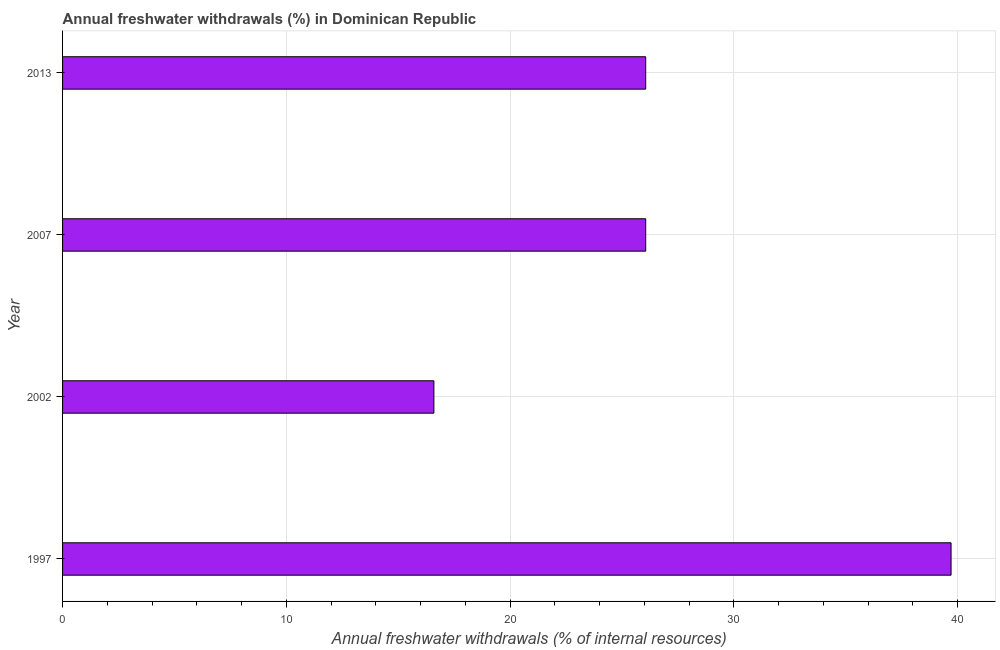Does the graph contain any zero values?
Your answer should be compact. No. What is the title of the graph?
Offer a very short reply. Annual freshwater withdrawals (%) in Dominican Republic. What is the label or title of the X-axis?
Your response must be concise. Annual freshwater withdrawals (% of internal resources). What is the label or title of the Y-axis?
Provide a succinct answer. Year. What is the annual freshwater withdrawals in 2002?
Keep it short and to the point. 16.6. Across all years, what is the maximum annual freshwater withdrawals?
Ensure brevity in your answer.  39.71. Across all years, what is the minimum annual freshwater withdrawals?
Give a very brief answer. 16.6. In which year was the annual freshwater withdrawals maximum?
Your response must be concise. 1997. In which year was the annual freshwater withdrawals minimum?
Give a very brief answer. 2002. What is the sum of the annual freshwater withdrawals?
Ensure brevity in your answer.  108.43. What is the difference between the annual freshwater withdrawals in 1997 and 2013?
Offer a terse response. 13.65. What is the average annual freshwater withdrawals per year?
Your response must be concise. 27.11. What is the median annual freshwater withdrawals?
Your answer should be very brief. 26.06. In how many years, is the annual freshwater withdrawals greater than 26 %?
Your answer should be very brief. 3. Do a majority of the years between 2002 and 2013 (inclusive) have annual freshwater withdrawals greater than 34 %?
Provide a succinct answer. No. What is the ratio of the annual freshwater withdrawals in 1997 to that in 2002?
Your answer should be compact. 2.39. Is the difference between the annual freshwater withdrawals in 2002 and 2007 greater than the difference between any two years?
Make the answer very short. No. What is the difference between the highest and the second highest annual freshwater withdrawals?
Ensure brevity in your answer.  13.65. What is the difference between the highest and the lowest annual freshwater withdrawals?
Your response must be concise. 23.11. Are all the bars in the graph horizontal?
Provide a succinct answer. Yes. How many years are there in the graph?
Give a very brief answer. 4. What is the difference between two consecutive major ticks on the X-axis?
Keep it short and to the point. 10. What is the Annual freshwater withdrawals (% of internal resources) of 1997?
Provide a short and direct response. 39.71. What is the Annual freshwater withdrawals (% of internal resources) of 2002?
Provide a succinct answer. 16.6. What is the Annual freshwater withdrawals (% of internal resources) of 2007?
Make the answer very short. 26.06. What is the Annual freshwater withdrawals (% of internal resources) of 2013?
Your response must be concise. 26.06. What is the difference between the Annual freshwater withdrawals (% of internal resources) in 1997 and 2002?
Make the answer very short. 23.11. What is the difference between the Annual freshwater withdrawals (% of internal resources) in 1997 and 2007?
Your answer should be compact. 13.65. What is the difference between the Annual freshwater withdrawals (% of internal resources) in 1997 and 2013?
Keep it short and to the point. 13.65. What is the difference between the Annual freshwater withdrawals (% of internal resources) in 2002 and 2007?
Ensure brevity in your answer.  -9.47. What is the difference between the Annual freshwater withdrawals (% of internal resources) in 2002 and 2013?
Keep it short and to the point. -9.47. What is the difference between the Annual freshwater withdrawals (% of internal resources) in 2007 and 2013?
Provide a succinct answer. 0. What is the ratio of the Annual freshwater withdrawals (% of internal resources) in 1997 to that in 2002?
Offer a very short reply. 2.39. What is the ratio of the Annual freshwater withdrawals (% of internal resources) in 1997 to that in 2007?
Your response must be concise. 1.52. What is the ratio of the Annual freshwater withdrawals (% of internal resources) in 1997 to that in 2013?
Your response must be concise. 1.52. What is the ratio of the Annual freshwater withdrawals (% of internal resources) in 2002 to that in 2007?
Make the answer very short. 0.64. What is the ratio of the Annual freshwater withdrawals (% of internal resources) in 2002 to that in 2013?
Make the answer very short. 0.64. 